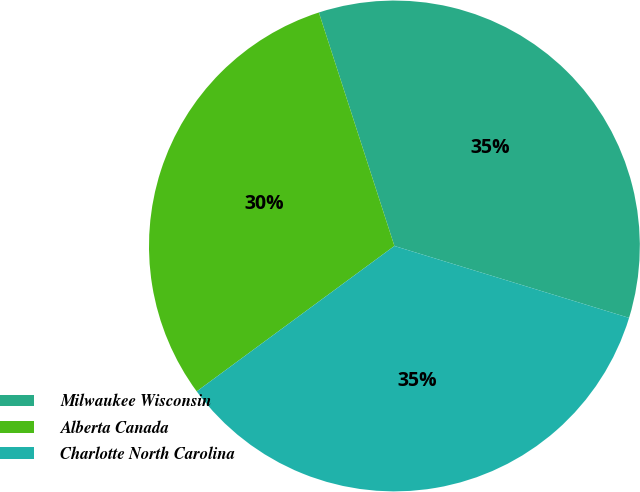<chart> <loc_0><loc_0><loc_500><loc_500><pie_chart><fcel>Milwaukee Wisconsin<fcel>Alberta Canada<fcel>Charlotte North Carolina<nl><fcel>34.71%<fcel>30.11%<fcel>35.17%<nl></chart> 